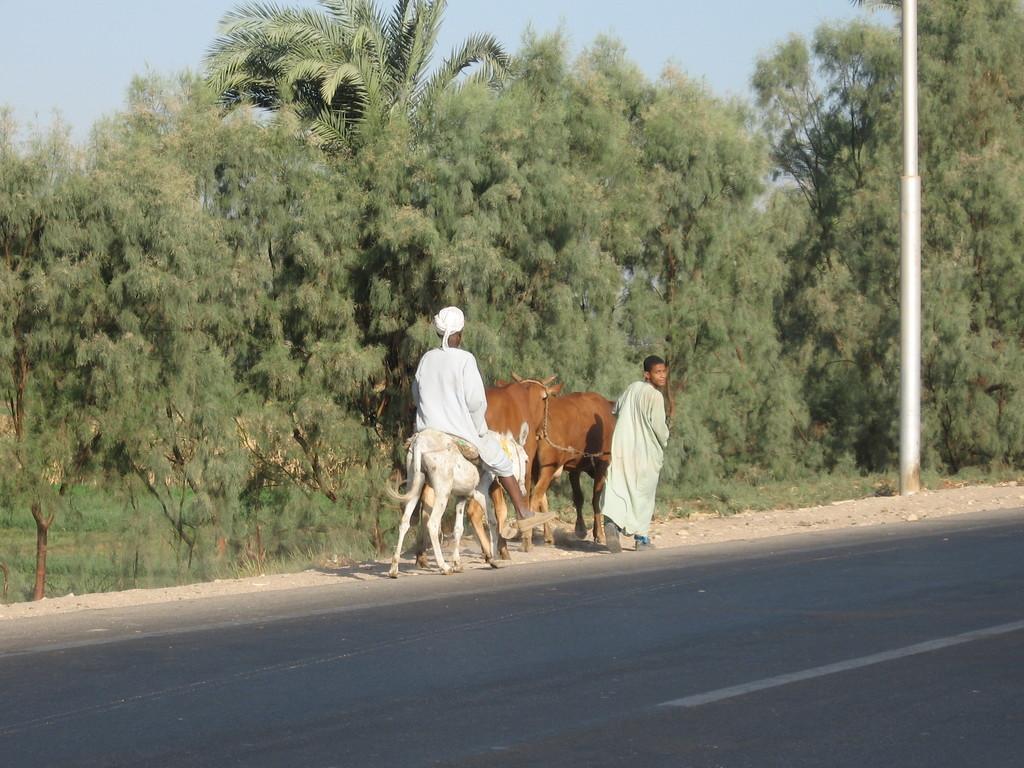How would you summarize this image in a sentence or two? In the center of the image, we can see a person sitting on an animal and there are some other animals and a person. In the background, there are trees. At the bottom, there is road and at the top, there is sky. 